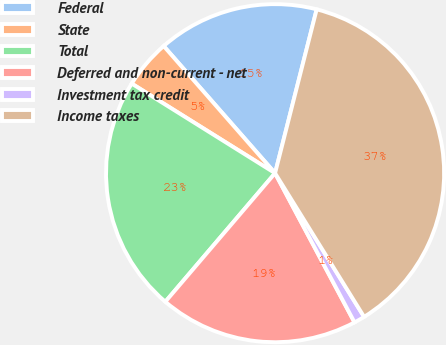Convert chart. <chart><loc_0><loc_0><loc_500><loc_500><pie_chart><fcel>Federal<fcel>State<fcel>Total<fcel>Deferred and non-current - net<fcel>Investment tax credit<fcel>Income taxes<nl><fcel>15.41%<fcel>4.66%<fcel>22.64%<fcel>19.03%<fcel>1.04%<fcel>37.21%<nl></chart> 